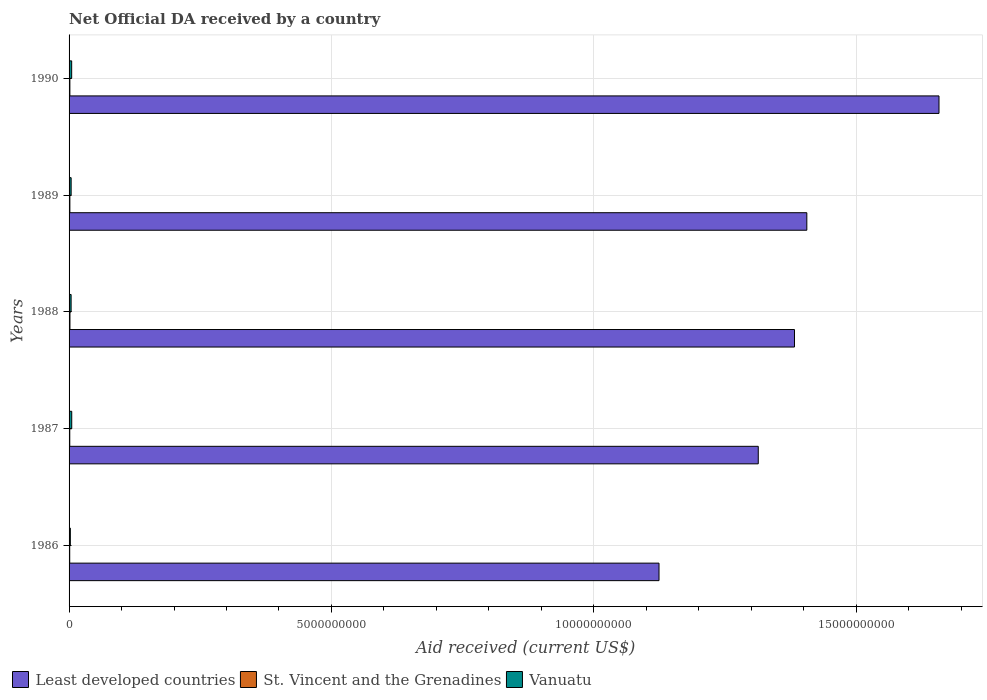Are the number of bars per tick equal to the number of legend labels?
Provide a succinct answer. Yes. Are the number of bars on each tick of the Y-axis equal?
Provide a succinct answer. Yes. How many bars are there on the 2nd tick from the top?
Ensure brevity in your answer.  3. What is the net official development assistance aid received in St. Vincent and the Grenadines in 1987?
Your answer should be compact. 1.33e+07. Across all years, what is the maximum net official development assistance aid received in St. Vincent and the Grenadines?
Ensure brevity in your answer.  1.70e+07. Across all years, what is the minimum net official development assistance aid received in Least developed countries?
Give a very brief answer. 1.12e+1. In which year was the net official development assistance aid received in Vanuatu maximum?
Provide a succinct answer. 1987. In which year was the net official development assistance aid received in Vanuatu minimum?
Your answer should be compact. 1986. What is the total net official development assistance aid received in Least developed countries in the graph?
Give a very brief answer. 6.88e+1. What is the difference between the net official development assistance aid received in Least developed countries in 1988 and that in 1990?
Ensure brevity in your answer.  -2.75e+09. What is the difference between the net official development assistance aid received in Least developed countries in 1989 and the net official development assistance aid received in St. Vincent and the Grenadines in 1986?
Keep it short and to the point. 1.40e+1. What is the average net official development assistance aid received in Least developed countries per year?
Offer a very short reply. 1.38e+1. In the year 1987, what is the difference between the net official development assistance aid received in Vanuatu and net official development assistance aid received in St. Vincent and the Grenadines?
Offer a terse response. 3.76e+07. What is the ratio of the net official development assistance aid received in St. Vincent and the Grenadines in 1986 to that in 1989?
Keep it short and to the point. 0.81. Is the difference between the net official development assistance aid received in Vanuatu in 1988 and 1990 greater than the difference between the net official development assistance aid received in St. Vincent and the Grenadines in 1988 and 1990?
Keep it short and to the point. No. What is the difference between the highest and the second highest net official development assistance aid received in Vanuatu?
Your answer should be compact. 1.36e+06. What is the difference between the highest and the lowest net official development assistance aid received in St. Vincent and the Grenadines?
Your answer should be very brief. 4.54e+06. What does the 1st bar from the top in 1990 represents?
Your response must be concise. Vanuatu. What does the 1st bar from the bottom in 1990 represents?
Provide a succinct answer. Least developed countries. How many bars are there?
Provide a short and direct response. 15. How many legend labels are there?
Give a very brief answer. 3. What is the title of the graph?
Give a very brief answer. Net Official DA received by a country. What is the label or title of the X-axis?
Your response must be concise. Aid received (current US$). What is the label or title of the Y-axis?
Your answer should be compact. Years. What is the Aid received (current US$) of Least developed countries in 1986?
Offer a very short reply. 1.12e+1. What is the Aid received (current US$) of St. Vincent and the Grenadines in 1986?
Provide a short and direct response. 1.24e+07. What is the Aid received (current US$) in Vanuatu in 1986?
Provide a succinct answer. 2.43e+07. What is the Aid received (current US$) in Least developed countries in 1987?
Your response must be concise. 1.31e+1. What is the Aid received (current US$) in St. Vincent and the Grenadines in 1987?
Your response must be concise. 1.33e+07. What is the Aid received (current US$) of Vanuatu in 1987?
Keep it short and to the point. 5.09e+07. What is the Aid received (current US$) of Least developed countries in 1988?
Provide a succinct answer. 1.38e+1. What is the Aid received (current US$) of St. Vincent and the Grenadines in 1988?
Your response must be concise. 1.70e+07. What is the Aid received (current US$) of Vanuatu in 1988?
Give a very brief answer. 3.89e+07. What is the Aid received (current US$) of Least developed countries in 1989?
Ensure brevity in your answer.  1.41e+1. What is the Aid received (current US$) of St. Vincent and the Grenadines in 1989?
Your response must be concise. 1.53e+07. What is the Aid received (current US$) in Vanuatu in 1989?
Keep it short and to the point. 3.95e+07. What is the Aid received (current US$) of Least developed countries in 1990?
Offer a very short reply. 1.66e+1. What is the Aid received (current US$) of St. Vincent and the Grenadines in 1990?
Keep it short and to the point. 1.54e+07. What is the Aid received (current US$) in Vanuatu in 1990?
Make the answer very short. 4.95e+07. Across all years, what is the maximum Aid received (current US$) of Least developed countries?
Keep it short and to the point. 1.66e+1. Across all years, what is the maximum Aid received (current US$) in St. Vincent and the Grenadines?
Keep it short and to the point. 1.70e+07. Across all years, what is the maximum Aid received (current US$) of Vanuatu?
Provide a succinct answer. 5.09e+07. Across all years, what is the minimum Aid received (current US$) of Least developed countries?
Provide a succinct answer. 1.12e+1. Across all years, what is the minimum Aid received (current US$) of St. Vincent and the Grenadines?
Your answer should be compact. 1.24e+07. Across all years, what is the minimum Aid received (current US$) in Vanuatu?
Offer a very short reply. 2.43e+07. What is the total Aid received (current US$) of Least developed countries in the graph?
Offer a very short reply. 6.88e+1. What is the total Aid received (current US$) in St. Vincent and the Grenadines in the graph?
Keep it short and to the point. 7.34e+07. What is the total Aid received (current US$) of Vanuatu in the graph?
Offer a very short reply. 2.03e+08. What is the difference between the Aid received (current US$) in Least developed countries in 1986 and that in 1987?
Your response must be concise. -1.89e+09. What is the difference between the Aid received (current US$) of St. Vincent and the Grenadines in 1986 and that in 1987?
Provide a short and direct response. -9.30e+05. What is the difference between the Aid received (current US$) in Vanuatu in 1986 and that in 1987?
Provide a succinct answer. -2.66e+07. What is the difference between the Aid received (current US$) of Least developed countries in 1986 and that in 1988?
Provide a short and direct response. -2.58e+09. What is the difference between the Aid received (current US$) in St. Vincent and the Grenadines in 1986 and that in 1988?
Keep it short and to the point. -4.54e+06. What is the difference between the Aid received (current US$) in Vanuatu in 1986 and that in 1988?
Your answer should be compact. -1.47e+07. What is the difference between the Aid received (current US$) in Least developed countries in 1986 and that in 1989?
Keep it short and to the point. -2.82e+09. What is the difference between the Aid received (current US$) of St. Vincent and the Grenadines in 1986 and that in 1989?
Your answer should be very brief. -2.89e+06. What is the difference between the Aid received (current US$) in Vanuatu in 1986 and that in 1989?
Your answer should be very brief. -1.52e+07. What is the difference between the Aid received (current US$) in Least developed countries in 1986 and that in 1990?
Ensure brevity in your answer.  -5.34e+09. What is the difference between the Aid received (current US$) of St. Vincent and the Grenadines in 1986 and that in 1990?
Offer a terse response. -2.96e+06. What is the difference between the Aid received (current US$) of Vanuatu in 1986 and that in 1990?
Your answer should be very brief. -2.53e+07. What is the difference between the Aid received (current US$) of Least developed countries in 1987 and that in 1988?
Your response must be concise. -6.90e+08. What is the difference between the Aid received (current US$) in St. Vincent and the Grenadines in 1987 and that in 1988?
Offer a terse response. -3.61e+06. What is the difference between the Aid received (current US$) in Vanuatu in 1987 and that in 1988?
Your answer should be compact. 1.20e+07. What is the difference between the Aid received (current US$) in Least developed countries in 1987 and that in 1989?
Give a very brief answer. -9.25e+08. What is the difference between the Aid received (current US$) of St. Vincent and the Grenadines in 1987 and that in 1989?
Ensure brevity in your answer.  -1.96e+06. What is the difference between the Aid received (current US$) in Vanuatu in 1987 and that in 1989?
Ensure brevity in your answer.  1.14e+07. What is the difference between the Aid received (current US$) of Least developed countries in 1987 and that in 1990?
Ensure brevity in your answer.  -3.44e+09. What is the difference between the Aid received (current US$) in St. Vincent and the Grenadines in 1987 and that in 1990?
Provide a short and direct response. -2.03e+06. What is the difference between the Aid received (current US$) of Vanuatu in 1987 and that in 1990?
Ensure brevity in your answer.  1.36e+06. What is the difference between the Aid received (current US$) of Least developed countries in 1988 and that in 1989?
Your answer should be compact. -2.35e+08. What is the difference between the Aid received (current US$) of St. Vincent and the Grenadines in 1988 and that in 1989?
Give a very brief answer. 1.65e+06. What is the difference between the Aid received (current US$) in Vanuatu in 1988 and that in 1989?
Keep it short and to the point. -5.80e+05. What is the difference between the Aid received (current US$) in Least developed countries in 1988 and that in 1990?
Offer a terse response. -2.75e+09. What is the difference between the Aid received (current US$) in St. Vincent and the Grenadines in 1988 and that in 1990?
Give a very brief answer. 1.58e+06. What is the difference between the Aid received (current US$) in Vanuatu in 1988 and that in 1990?
Give a very brief answer. -1.06e+07. What is the difference between the Aid received (current US$) in Least developed countries in 1989 and that in 1990?
Your answer should be compact. -2.52e+09. What is the difference between the Aid received (current US$) of Vanuatu in 1989 and that in 1990?
Provide a short and direct response. -1.00e+07. What is the difference between the Aid received (current US$) in Least developed countries in 1986 and the Aid received (current US$) in St. Vincent and the Grenadines in 1987?
Provide a short and direct response. 1.12e+1. What is the difference between the Aid received (current US$) in Least developed countries in 1986 and the Aid received (current US$) in Vanuatu in 1987?
Provide a short and direct response. 1.12e+1. What is the difference between the Aid received (current US$) of St. Vincent and the Grenadines in 1986 and the Aid received (current US$) of Vanuatu in 1987?
Make the answer very short. -3.85e+07. What is the difference between the Aid received (current US$) of Least developed countries in 1986 and the Aid received (current US$) of St. Vincent and the Grenadines in 1988?
Provide a short and direct response. 1.12e+1. What is the difference between the Aid received (current US$) in Least developed countries in 1986 and the Aid received (current US$) in Vanuatu in 1988?
Your answer should be very brief. 1.12e+1. What is the difference between the Aid received (current US$) in St. Vincent and the Grenadines in 1986 and the Aid received (current US$) in Vanuatu in 1988?
Provide a succinct answer. -2.65e+07. What is the difference between the Aid received (current US$) of Least developed countries in 1986 and the Aid received (current US$) of St. Vincent and the Grenadines in 1989?
Give a very brief answer. 1.12e+1. What is the difference between the Aid received (current US$) of Least developed countries in 1986 and the Aid received (current US$) of Vanuatu in 1989?
Your answer should be compact. 1.12e+1. What is the difference between the Aid received (current US$) of St. Vincent and the Grenadines in 1986 and the Aid received (current US$) of Vanuatu in 1989?
Provide a succinct answer. -2.71e+07. What is the difference between the Aid received (current US$) in Least developed countries in 1986 and the Aid received (current US$) in St. Vincent and the Grenadines in 1990?
Give a very brief answer. 1.12e+1. What is the difference between the Aid received (current US$) in Least developed countries in 1986 and the Aid received (current US$) in Vanuatu in 1990?
Your answer should be very brief. 1.12e+1. What is the difference between the Aid received (current US$) of St. Vincent and the Grenadines in 1986 and the Aid received (current US$) of Vanuatu in 1990?
Ensure brevity in your answer.  -3.71e+07. What is the difference between the Aid received (current US$) of Least developed countries in 1987 and the Aid received (current US$) of St. Vincent and the Grenadines in 1988?
Provide a succinct answer. 1.31e+1. What is the difference between the Aid received (current US$) in Least developed countries in 1987 and the Aid received (current US$) in Vanuatu in 1988?
Ensure brevity in your answer.  1.31e+1. What is the difference between the Aid received (current US$) in St. Vincent and the Grenadines in 1987 and the Aid received (current US$) in Vanuatu in 1988?
Keep it short and to the point. -2.56e+07. What is the difference between the Aid received (current US$) in Least developed countries in 1987 and the Aid received (current US$) in St. Vincent and the Grenadines in 1989?
Make the answer very short. 1.31e+1. What is the difference between the Aid received (current US$) in Least developed countries in 1987 and the Aid received (current US$) in Vanuatu in 1989?
Your answer should be very brief. 1.31e+1. What is the difference between the Aid received (current US$) of St. Vincent and the Grenadines in 1987 and the Aid received (current US$) of Vanuatu in 1989?
Offer a very short reply. -2.62e+07. What is the difference between the Aid received (current US$) in Least developed countries in 1987 and the Aid received (current US$) in St. Vincent and the Grenadines in 1990?
Ensure brevity in your answer.  1.31e+1. What is the difference between the Aid received (current US$) in Least developed countries in 1987 and the Aid received (current US$) in Vanuatu in 1990?
Provide a succinct answer. 1.31e+1. What is the difference between the Aid received (current US$) of St. Vincent and the Grenadines in 1987 and the Aid received (current US$) of Vanuatu in 1990?
Provide a short and direct response. -3.62e+07. What is the difference between the Aid received (current US$) of Least developed countries in 1988 and the Aid received (current US$) of St. Vincent and the Grenadines in 1989?
Your response must be concise. 1.38e+1. What is the difference between the Aid received (current US$) in Least developed countries in 1988 and the Aid received (current US$) in Vanuatu in 1989?
Offer a very short reply. 1.38e+1. What is the difference between the Aid received (current US$) in St. Vincent and the Grenadines in 1988 and the Aid received (current US$) in Vanuatu in 1989?
Ensure brevity in your answer.  -2.26e+07. What is the difference between the Aid received (current US$) in Least developed countries in 1988 and the Aid received (current US$) in St. Vincent and the Grenadines in 1990?
Offer a terse response. 1.38e+1. What is the difference between the Aid received (current US$) in Least developed countries in 1988 and the Aid received (current US$) in Vanuatu in 1990?
Give a very brief answer. 1.38e+1. What is the difference between the Aid received (current US$) in St. Vincent and the Grenadines in 1988 and the Aid received (current US$) in Vanuatu in 1990?
Make the answer very short. -3.26e+07. What is the difference between the Aid received (current US$) in Least developed countries in 1989 and the Aid received (current US$) in St. Vincent and the Grenadines in 1990?
Ensure brevity in your answer.  1.40e+1. What is the difference between the Aid received (current US$) in Least developed countries in 1989 and the Aid received (current US$) in Vanuatu in 1990?
Give a very brief answer. 1.40e+1. What is the difference between the Aid received (current US$) in St. Vincent and the Grenadines in 1989 and the Aid received (current US$) in Vanuatu in 1990?
Offer a very short reply. -3.42e+07. What is the average Aid received (current US$) in Least developed countries per year?
Provide a succinct answer. 1.38e+1. What is the average Aid received (current US$) of St. Vincent and the Grenadines per year?
Keep it short and to the point. 1.47e+07. What is the average Aid received (current US$) in Vanuatu per year?
Your answer should be very brief. 4.06e+07. In the year 1986, what is the difference between the Aid received (current US$) in Least developed countries and Aid received (current US$) in St. Vincent and the Grenadines?
Your response must be concise. 1.12e+1. In the year 1986, what is the difference between the Aid received (current US$) of Least developed countries and Aid received (current US$) of Vanuatu?
Give a very brief answer. 1.12e+1. In the year 1986, what is the difference between the Aid received (current US$) of St. Vincent and the Grenadines and Aid received (current US$) of Vanuatu?
Offer a terse response. -1.19e+07. In the year 1987, what is the difference between the Aid received (current US$) in Least developed countries and Aid received (current US$) in St. Vincent and the Grenadines?
Give a very brief answer. 1.31e+1. In the year 1987, what is the difference between the Aid received (current US$) in Least developed countries and Aid received (current US$) in Vanuatu?
Keep it short and to the point. 1.31e+1. In the year 1987, what is the difference between the Aid received (current US$) of St. Vincent and the Grenadines and Aid received (current US$) of Vanuatu?
Your answer should be very brief. -3.76e+07. In the year 1988, what is the difference between the Aid received (current US$) in Least developed countries and Aid received (current US$) in St. Vincent and the Grenadines?
Provide a succinct answer. 1.38e+1. In the year 1988, what is the difference between the Aid received (current US$) in Least developed countries and Aid received (current US$) in Vanuatu?
Offer a terse response. 1.38e+1. In the year 1988, what is the difference between the Aid received (current US$) in St. Vincent and the Grenadines and Aid received (current US$) in Vanuatu?
Provide a succinct answer. -2.20e+07. In the year 1989, what is the difference between the Aid received (current US$) in Least developed countries and Aid received (current US$) in St. Vincent and the Grenadines?
Your answer should be compact. 1.40e+1. In the year 1989, what is the difference between the Aid received (current US$) of Least developed countries and Aid received (current US$) of Vanuatu?
Offer a terse response. 1.40e+1. In the year 1989, what is the difference between the Aid received (current US$) in St. Vincent and the Grenadines and Aid received (current US$) in Vanuatu?
Your response must be concise. -2.42e+07. In the year 1990, what is the difference between the Aid received (current US$) in Least developed countries and Aid received (current US$) in St. Vincent and the Grenadines?
Provide a short and direct response. 1.66e+1. In the year 1990, what is the difference between the Aid received (current US$) of Least developed countries and Aid received (current US$) of Vanuatu?
Your answer should be very brief. 1.65e+1. In the year 1990, what is the difference between the Aid received (current US$) in St. Vincent and the Grenadines and Aid received (current US$) in Vanuatu?
Offer a terse response. -3.42e+07. What is the ratio of the Aid received (current US$) in Least developed countries in 1986 to that in 1987?
Give a very brief answer. 0.86. What is the ratio of the Aid received (current US$) in St. Vincent and the Grenadines in 1986 to that in 1987?
Provide a succinct answer. 0.93. What is the ratio of the Aid received (current US$) in Vanuatu in 1986 to that in 1987?
Your answer should be very brief. 0.48. What is the ratio of the Aid received (current US$) of Least developed countries in 1986 to that in 1988?
Provide a succinct answer. 0.81. What is the ratio of the Aid received (current US$) in St. Vincent and the Grenadines in 1986 to that in 1988?
Your answer should be very brief. 0.73. What is the ratio of the Aid received (current US$) of Vanuatu in 1986 to that in 1988?
Make the answer very short. 0.62. What is the ratio of the Aid received (current US$) in Least developed countries in 1986 to that in 1989?
Make the answer very short. 0.8. What is the ratio of the Aid received (current US$) in St. Vincent and the Grenadines in 1986 to that in 1989?
Provide a succinct answer. 0.81. What is the ratio of the Aid received (current US$) of Vanuatu in 1986 to that in 1989?
Your response must be concise. 0.61. What is the ratio of the Aid received (current US$) in Least developed countries in 1986 to that in 1990?
Give a very brief answer. 0.68. What is the ratio of the Aid received (current US$) in St. Vincent and the Grenadines in 1986 to that in 1990?
Provide a short and direct response. 0.81. What is the ratio of the Aid received (current US$) in Vanuatu in 1986 to that in 1990?
Ensure brevity in your answer.  0.49. What is the ratio of the Aid received (current US$) in Least developed countries in 1987 to that in 1988?
Provide a short and direct response. 0.95. What is the ratio of the Aid received (current US$) in St. Vincent and the Grenadines in 1987 to that in 1988?
Offer a terse response. 0.79. What is the ratio of the Aid received (current US$) in Vanuatu in 1987 to that in 1988?
Your response must be concise. 1.31. What is the ratio of the Aid received (current US$) of Least developed countries in 1987 to that in 1989?
Your answer should be very brief. 0.93. What is the ratio of the Aid received (current US$) of St. Vincent and the Grenadines in 1987 to that in 1989?
Ensure brevity in your answer.  0.87. What is the ratio of the Aid received (current US$) in Vanuatu in 1987 to that in 1989?
Your answer should be very brief. 1.29. What is the ratio of the Aid received (current US$) of Least developed countries in 1987 to that in 1990?
Your answer should be very brief. 0.79. What is the ratio of the Aid received (current US$) of St. Vincent and the Grenadines in 1987 to that in 1990?
Keep it short and to the point. 0.87. What is the ratio of the Aid received (current US$) of Vanuatu in 1987 to that in 1990?
Your response must be concise. 1.03. What is the ratio of the Aid received (current US$) of Least developed countries in 1988 to that in 1989?
Your answer should be very brief. 0.98. What is the ratio of the Aid received (current US$) of St. Vincent and the Grenadines in 1988 to that in 1989?
Provide a short and direct response. 1.11. What is the ratio of the Aid received (current US$) of Vanuatu in 1988 to that in 1989?
Give a very brief answer. 0.99. What is the ratio of the Aid received (current US$) in Least developed countries in 1988 to that in 1990?
Offer a terse response. 0.83. What is the ratio of the Aid received (current US$) of St. Vincent and the Grenadines in 1988 to that in 1990?
Offer a very short reply. 1.1. What is the ratio of the Aid received (current US$) of Vanuatu in 1988 to that in 1990?
Provide a short and direct response. 0.79. What is the ratio of the Aid received (current US$) of Least developed countries in 1989 to that in 1990?
Your answer should be compact. 0.85. What is the ratio of the Aid received (current US$) in St. Vincent and the Grenadines in 1989 to that in 1990?
Provide a succinct answer. 1. What is the ratio of the Aid received (current US$) in Vanuatu in 1989 to that in 1990?
Provide a short and direct response. 0.8. What is the difference between the highest and the second highest Aid received (current US$) of Least developed countries?
Make the answer very short. 2.52e+09. What is the difference between the highest and the second highest Aid received (current US$) of St. Vincent and the Grenadines?
Keep it short and to the point. 1.58e+06. What is the difference between the highest and the second highest Aid received (current US$) in Vanuatu?
Your answer should be compact. 1.36e+06. What is the difference between the highest and the lowest Aid received (current US$) in Least developed countries?
Offer a terse response. 5.34e+09. What is the difference between the highest and the lowest Aid received (current US$) of St. Vincent and the Grenadines?
Offer a very short reply. 4.54e+06. What is the difference between the highest and the lowest Aid received (current US$) of Vanuatu?
Give a very brief answer. 2.66e+07. 